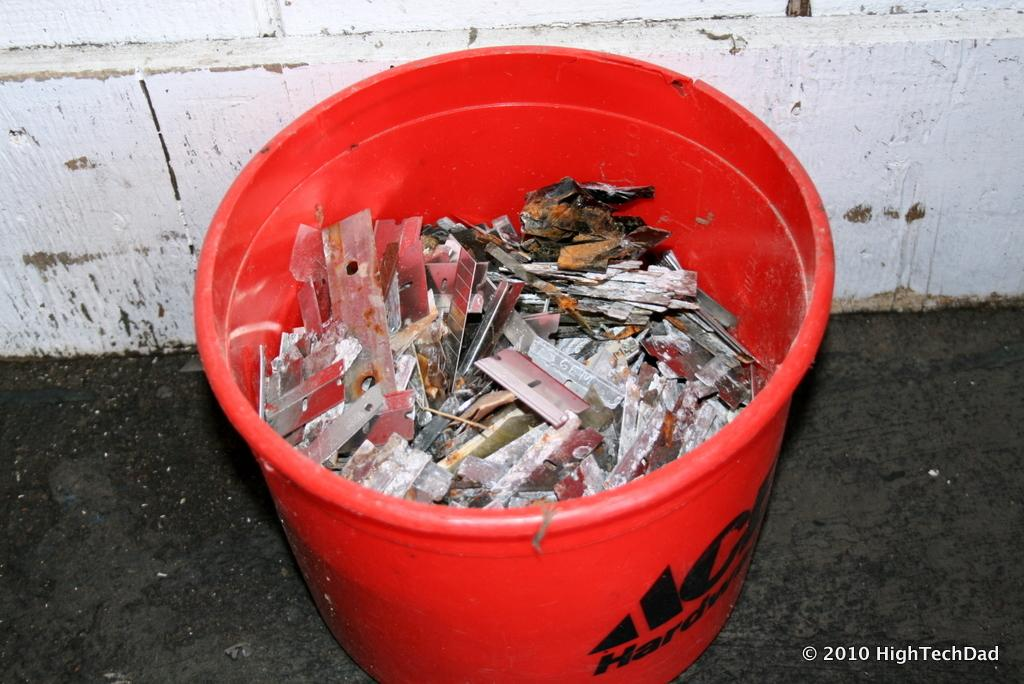<image>
Relay a brief, clear account of the picture shown. A red bucket from ACE has old razor blade piled up inside of it. 